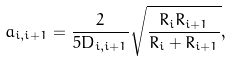<formula> <loc_0><loc_0><loc_500><loc_500>a _ { i , i + 1 } = \frac { 2 } { 5 D _ { i , i + 1 } } \sqrt { \frac { R _ { i } R _ { i + 1 } } { R _ { i } + R _ { i + 1 } } } ,</formula> 